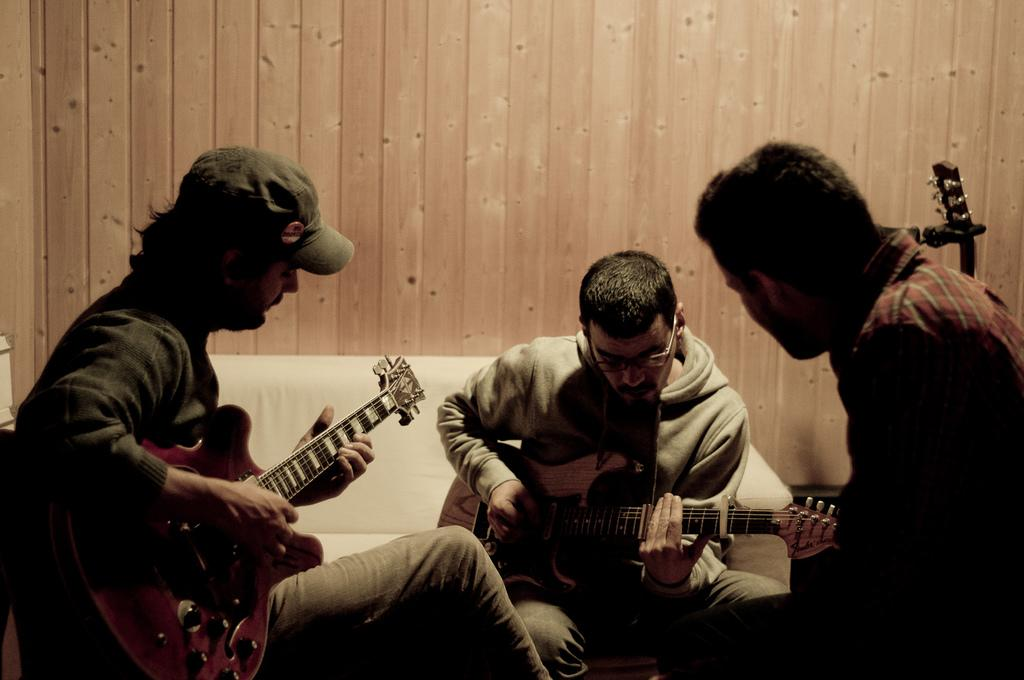How many people are present in the image? There are three people in the image. What are the people doing in the image? The people are sitting and playing a guitar. What type of furniture can be seen in the image? There is a couch with a white color in the image. What is the material of the wall visible in the background? The wall in the background is made of wood. What type of verse is being recited by the person wearing a sweater in the image? There is no person wearing a sweater in the image, and no verse is being recited. How does the love between the people in the image manifest itself? There is no indication of love between the people in the image. 